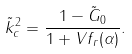<formula> <loc_0><loc_0><loc_500><loc_500>\tilde { k } _ { c } ^ { 2 } = \frac { 1 - \tilde { G } _ { 0 } } { 1 + V f _ { r } ( \alpha ) } .</formula> 